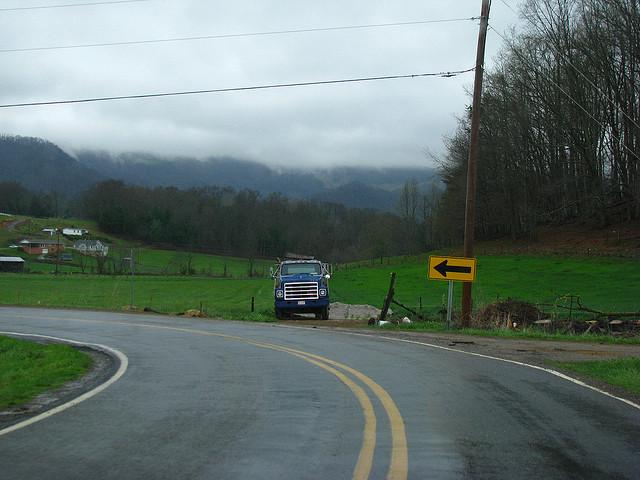What is curving in the photo?
Concise answer only. Road. How many arrows can you see?
Quick response, please. 1. Is the truck trying to get back onto the road?
Quick response, please. No. Is this a freeway?
Quick response, please. No. Is this a gravel road?
Quick response, please. No. Sunny or overcast?
Short answer required. Overcast. Is there a waterfall?
Keep it brief. No. Is there another person driving on the road?
Write a very short answer. No. What landforms are in the background?
Keep it brief. Mountains. 